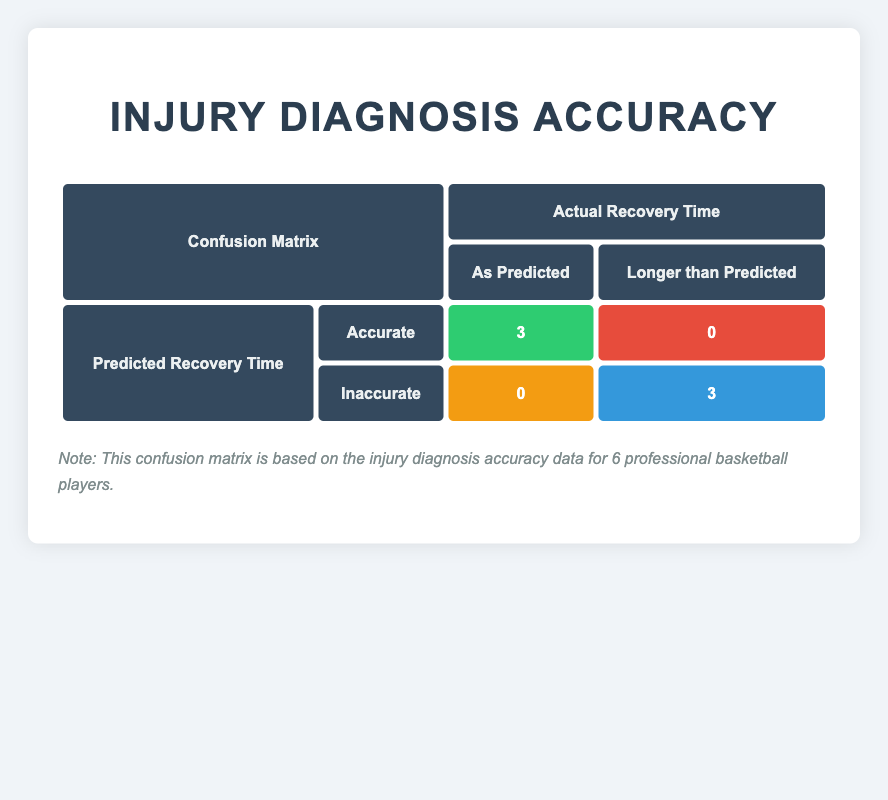What is the total number of accurate injury diagnoses? The matrix indicates that there are 3 true positives, where diagnoses were accurate, representing the accurate injury diagnoses.
Answer: 3 How many players had an inaccurate injury diagnosis? The matrix indicates that there are 3 true negatives (no inaccuracies) and 0 false negatives, thus implying that 3 players had an inaccurate diagnosis since all remaining players (6 total - 3 accurate) are considered inaccurate.
Answer: 3 Did LeBron James receive an accurate diagnosis for his injury? According to the table, LeBron James's injury diagnosis was labeled as inaccurate since his actual recovery time of 6 weeks differed from the predicted recovery time of 4 weeks.
Answer: No How many players were diagnosed accurately with a recovery time longer than predicted? The matrix shows that there were 0 true positives for longer than predicted, which means no players had accurate diagnoses while their actual recovery was longer than what was predicted.
Answer: 0 What is the ratio of accurate diagnoses to inaccurate diagnoses? There are 3 accurate diagnoses and 3 inaccurate diagnoses. Therefore, the ratio is 3:3, which simplifies to 1:1.
Answer: 1:1 Which player had the longest gap between predicted and actual recovery times? The table indicates that Kawhi Leonard had the longest gap, with a predicted recovery time of 8 months compared to an actual recovery time of 12 months, resulting in a 4-month gap.
Answer: Kawhi Leonard How many players had an actual recovery time shorter than predicted? None of the players in the matrix had an actual recovery time shorter than predicted since the table features no cases of false positives.
Answer: 0 What percentage of players had accurate diagnoses? There are 3 accurate diagnoses out of a total of 6 players, so the percentage is (3/6) * 100 = 50%.
Answer: 50% Was the injury diagnosis for Kevin Durant accurate? The table shows that Kevin Durant had both an actual recovery time and a predicted recovery time of 7 weeks, indicating that the diagnosis was accurate.
Answer: Yes 